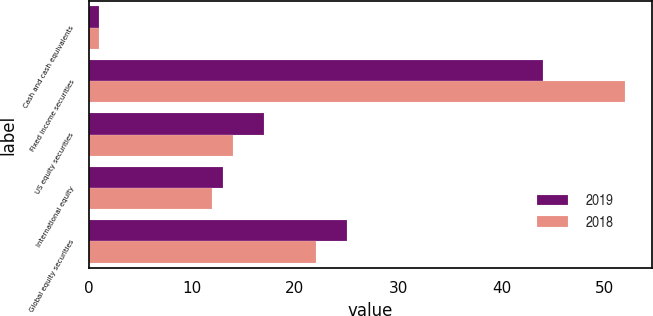Convert chart to OTSL. <chart><loc_0><loc_0><loc_500><loc_500><stacked_bar_chart><ecel><fcel>Cash and cash equivalents<fcel>Fixed income securities<fcel>US equity securities<fcel>International equity<fcel>Global equity securities<nl><fcel>2019<fcel>1<fcel>44<fcel>17<fcel>13<fcel>25<nl><fcel>2018<fcel>1<fcel>52<fcel>14<fcel>12<fcel>22<nl></chart> 